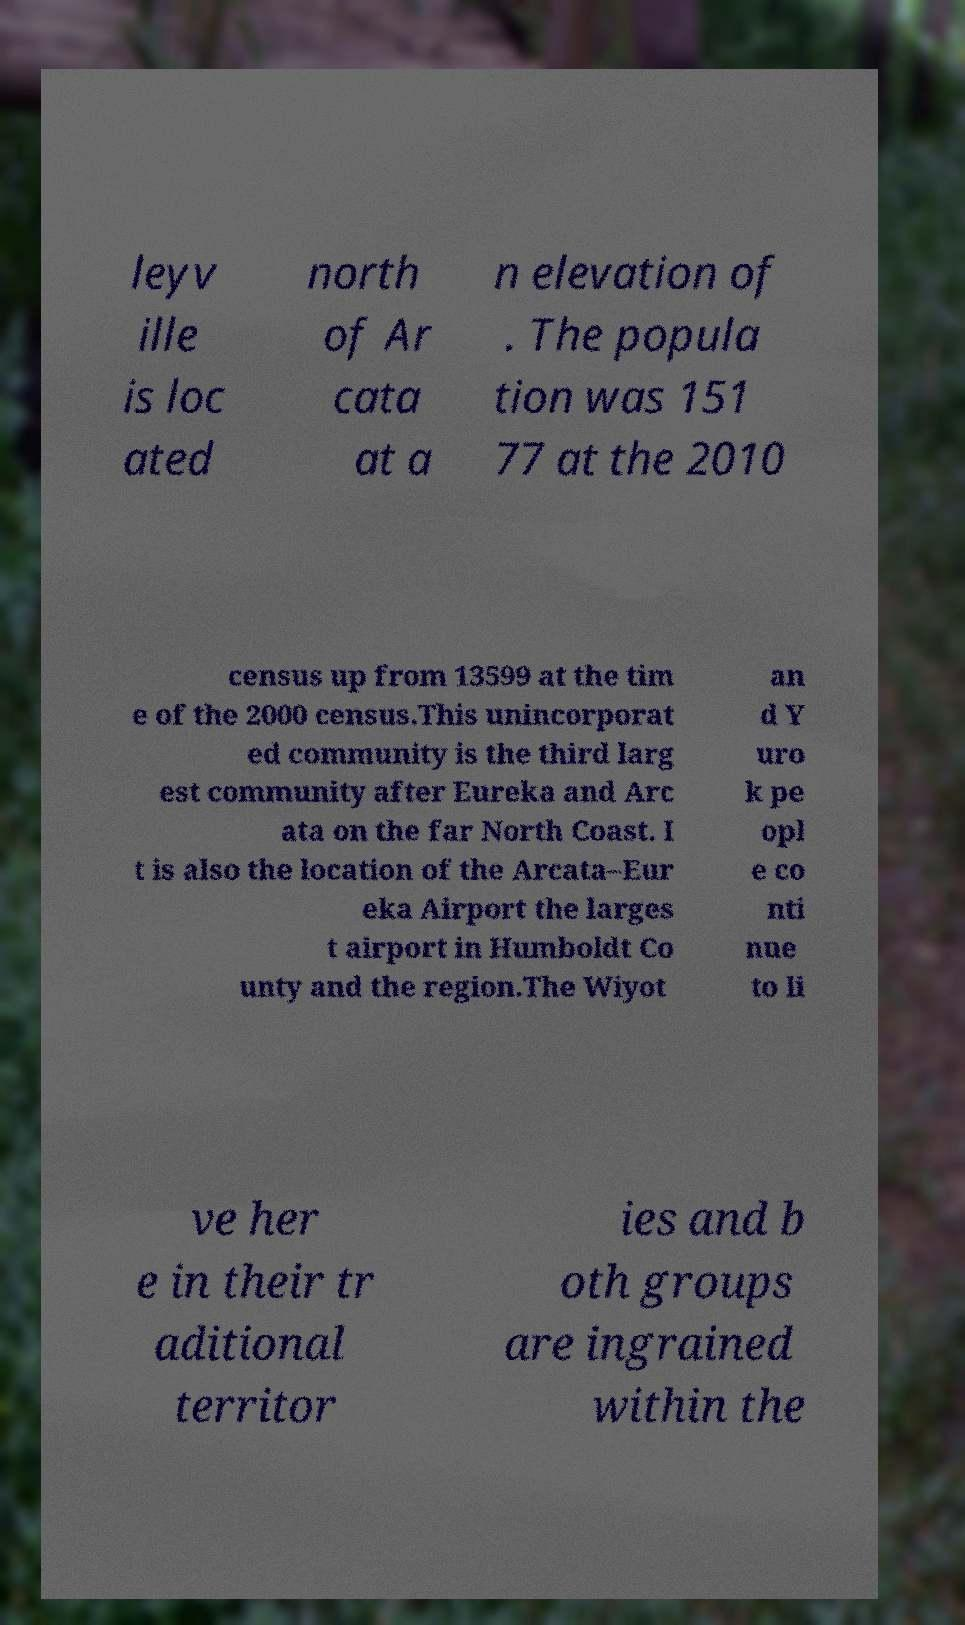Please read and relay the text visible in this image. What does it say? leyv ille is loc ated north of Ar cata at a n elevation of . The popula tion was 151 77 at the 2010 census up from 13599 at the tim e of the 2000 census.This unincorporat ed community is the third larg est community after Eureka and Arc ata on the far North Coast. I t is also the location of the Arcata–Eur eka Airport the larges t airport in Humboldt Co unty and the region.The Wiyot an d Y uro k pe opl e co nti nue to li ve her e in their tr aditional territor ies and b oth groups are ingrained within the 